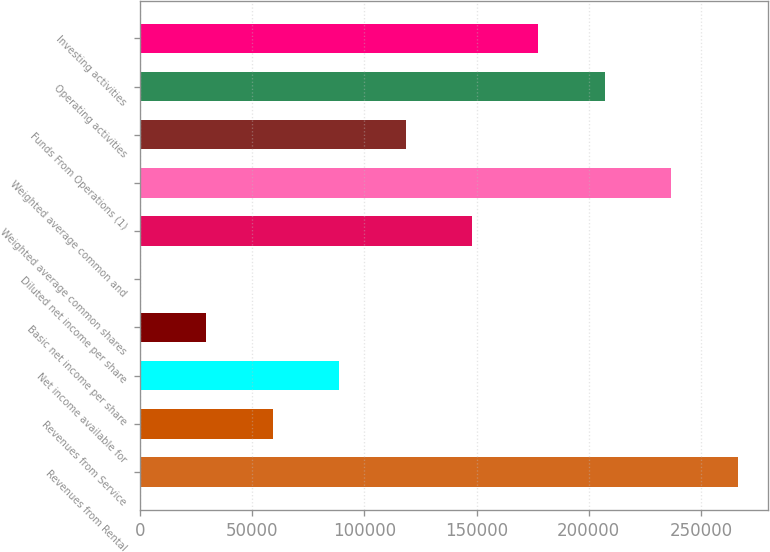Convert chart. <chart><loc_0><loc_0><loc_500><loc_500><bar_chart><fcel>Revenues from Rental<fcel>Revenues from Service<fcel>Net income available for<fcel>Basic net income per share<fcel>Diluted net income per share<fcel>Weighted average common shares<fcel>Weighted average common and<fcel>Funds From Operations (1)<fcel>Operating activities<fcel>Investing activities<nl><fcel>266382<fcel>59196.4<fcel>88794.4<fcel>29598.5<fcel>0.57<fcel>147990<fcel>236784<fcel>118392<fcel>207186<fcel>177588<nl></chart> 